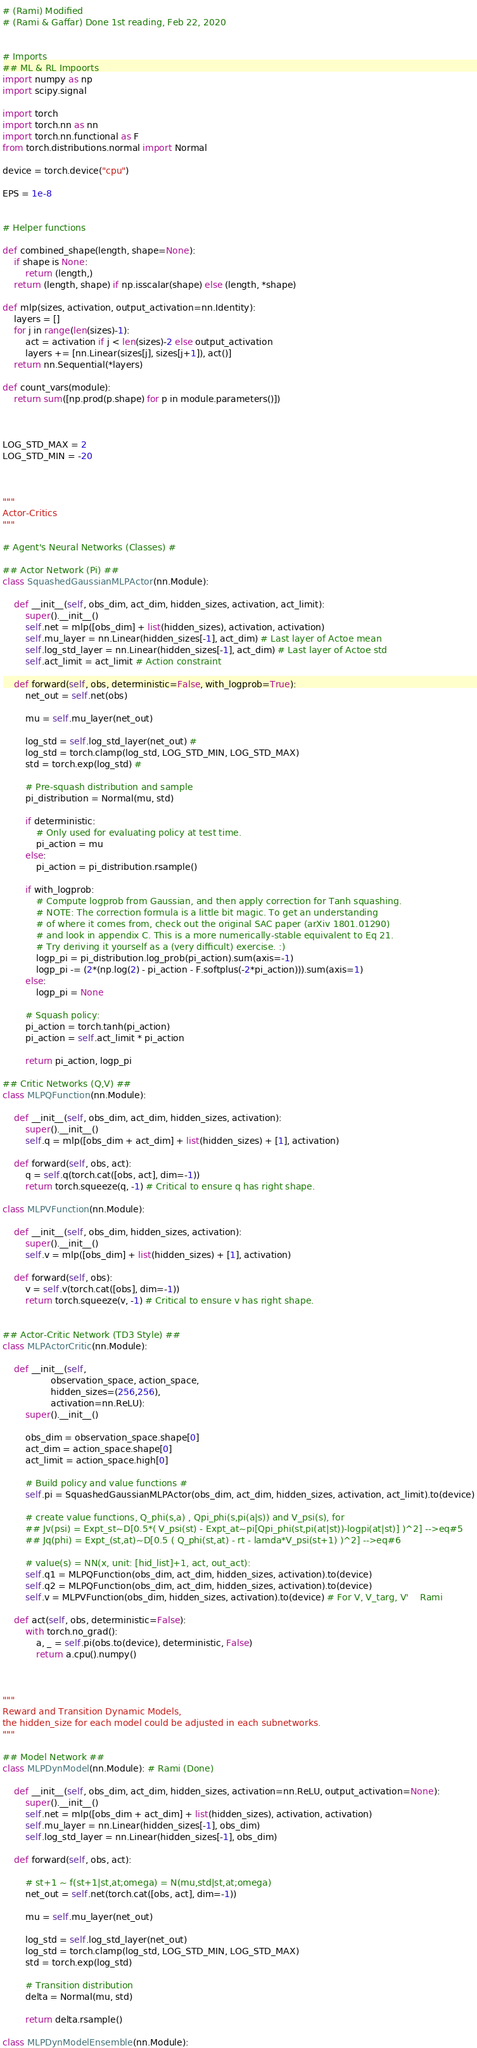<code> <loc_0><loc_0><loc_500><loc_500><_Python_># (Rami) Modified
# (Rami & Gaffar) Done 1st reading, Feb 22, 2020


# Imports
## ML & RL Impoorts
import numpy as np
import scipy.signal

import torch
import torch.nn as nn
import torch.nn.functional as F
from torch.distributions.normal import Normal

device = torch.device("cpu")

EPS = 1e-8


# Helper functions

def combined_shape(length, shape=None):
    if shape is None:
        return (length,)
    return (length, shape) if np.isscalar(shape) else (length, *shape)

def mlp(sizes, activation, output_activation=nn.Identity):
    layers = []
    for j in range(len(sizes)-1):
        act = activation if j < len(sizes)-2 else output_activation
        layers += [nn.Linear(sizes[j], sizes[j+1]), act()]
    return nn.Sequential(*layers)

def count_vars(module):
    return sum([np.prod(p.shape) for p in module.parameters()])



LOG_STD_MAX = 2
LOG_STD_MIN = -20



"""
Actor-Critics
"""

# Agent's Neural Networks (Classes) #

## Actor Network (Pi) ##
class SquashedGaussianMLPActor(nn.Module):

    def __init__(self, obs_dim, act_dim, hidden_sizes, activation, act_limit):
        super().__init__()
        self.net = mlp([obs_dim] + list(hidden_sizes), activation, activation)
        self.mu_layer = nn.Linear(hidden_sizes[-1], act_dim) # Last layer of Actoe mean
        self.log_std_layer = nn.Linear(hidden_sizes[-1], act_dim) # Last layer of Actoe std
        self.act_limit = act_limit # Action constraint

    def forward(self, obs, deterministic=False, with_logprob=True):
        net_out = self.net(obs)

        mu = self.mu_layer(net_out)

        log_std = self.log_std_layer(net_out) # 
        log_std = torch.clamp(log_std, LOG_STD_MIN, LOG_STD_MAX)
        std = torch.exp(log_std) # 

        # Pre-squash distribution and sample
        pi_distribution = Normal(mu, std)

        if deterministic:
            # Only used for evaluating policy at test time.
            pi_action = mu
        else:
            pi_action = pi_distribution.rsample()

        if with_logprob:
            # Compute logprob from Gaussian, and then apply correction for Tanh squashing.
            # NOTE: The correction formula is a little bit magic. To get an understanding 
            # of where it comes from, check out the original SAC paper (arXiv 1801.01290) 
            # and look in appendix C. This is a more numerically-stable equivalent to Eq 21.
            # Try deriving it yourself as a (very difficult) exercise. :)
            logp_pi = pi_distribution.log_prob(pi_action).sum(axis=-1)
            logp_pi -= (2*(np.log(2) - pi_action - F.softplus(-2*pi_action))).sum(axis=1)
        else:
            logp_pi = None

        # Squash policy:
        pi_action = torch.tanh(pi_action)
        pi_action = self.act_limit * pi_action

        return pi_action, logp_pi

## Critic Networks (Q,V) ##
class MLPQFunction(nn.Module):

    def __init__(self, obs_dim, act_dim, hidden_sizes, activation):
        super().__init__()
        self.q = mlp([obs_dim + act_dim] + list(hidden_sizes) + [1], activation)

    def forward(self, obs, act):
        q = self.q(torch.cat([obs, act], dim=-1))
        return torch.squeeze(q, -1) # Critical to ensure q has right shape.

class MLPVFunction(nn.Module):

    def __init__(self, obs_dim, hidden_sizes, activation):
        super().__init__()
        self.v = mlp([obs_dim] + list(hidden_sizes) + [1], activation)

    def forward(self, obs):
        v = self.v(torch.cat([obs], dim=-1))
        return torch.squeeze(v, -1) # Critical to ensure v has right shape.


## Actor-Critic Network (TD3 Style) ##
class MLPActorCritic(nn.Module):

    def __init__(self,
                 observation_space, action_space,
                 hidden_sizes=(256,256),
                 activation=nn.ReLU):
        super().__init__()

        obs_dim = observation_space.shape[0]
        act_dim = action_space.shape[0]
        act_limit = action_space.high[0]

        # Build policy and value functions #
        self.pi = SquashedGaussianMLPActor(obs_dim, act_dim, hidden_sizes, activation, act_limit).to(device)

        # create value functions, Q_phi(s,a) , Qpi_phi(s,pi(a|s)) and V_psi(s), for
        ## Jv(psi) = Expt_st~D[0.5*( V_psi(st) - Expt_at~pi[Qpi_phi(st,pi(at|st))-logpi(at|st)] )^2] -->eq#5
        ## Jq(phi) = Expt_(st,at)~D[0.5 ( Q_phi(st,at) - rt - lamda*V_psi(st+1) )^2] -->eq#6

        # value(s) = NN(x, unit: [hid_list]+1, act, out_act):
        self.q1 = MLPQFunction(obs_dim, act_dim, hidden_sizes, activation).to(device)
        self.q2 = MLPQFunction(obs_dim, act_dim, hidden_sizes, activation).to(device)
        self.v = MLPVFunction(obs_dim, hidden_sizes, activation).to(device) # For V, V_targ, V'    Rami

    def act(self, obs, deterministic=False):
        with torch.no_grad():
            a, _ = self.pi(obs.to(device), deterministic, False)
            return a.cpu().numpy()



"""
Reward and Transition Dynamic Models,
the hidden_size for each model could be adjusted in each subnetworks.
"""

## Model Network ##
class MLPDynModel(nn.Module): # Rami (Done)

    def __init__(self, obs_dim, act_dim, hidden_sizes, activation=nn.ReLU, output_activation=None):
        super().__init__()
        self.net = mlp([obs_dim + act_dim] + list(hidden_sizes), activation, activation)
        self.mu_layer = nn.Linear(hidden_sizes[-1], obs_dim)
        self.log_std_layer = nn.Linear(hidden_sizes[-1], obs_dim)

    def forward(self, obs, act):

        # st+1 ~ f(st+1|st,at;omega) = N(mu,std|st,at;omega)
        net_out = self.net(torch.cat([obs, act], dim=-1))

        mu = self.mu_layer(net_out)

        log_std = self.log_std_layer(net_out)
        log_std = torch.clamp(log_std, LOG_STD_MIN, LOG_STD_MAX)
        std = torch.exp(log_std) 

        # Transition distribution 
        delta = Normal(mu, std)

        return delta.rsample()

class MLPDynModelEnsemble(nn.Module):</code> 